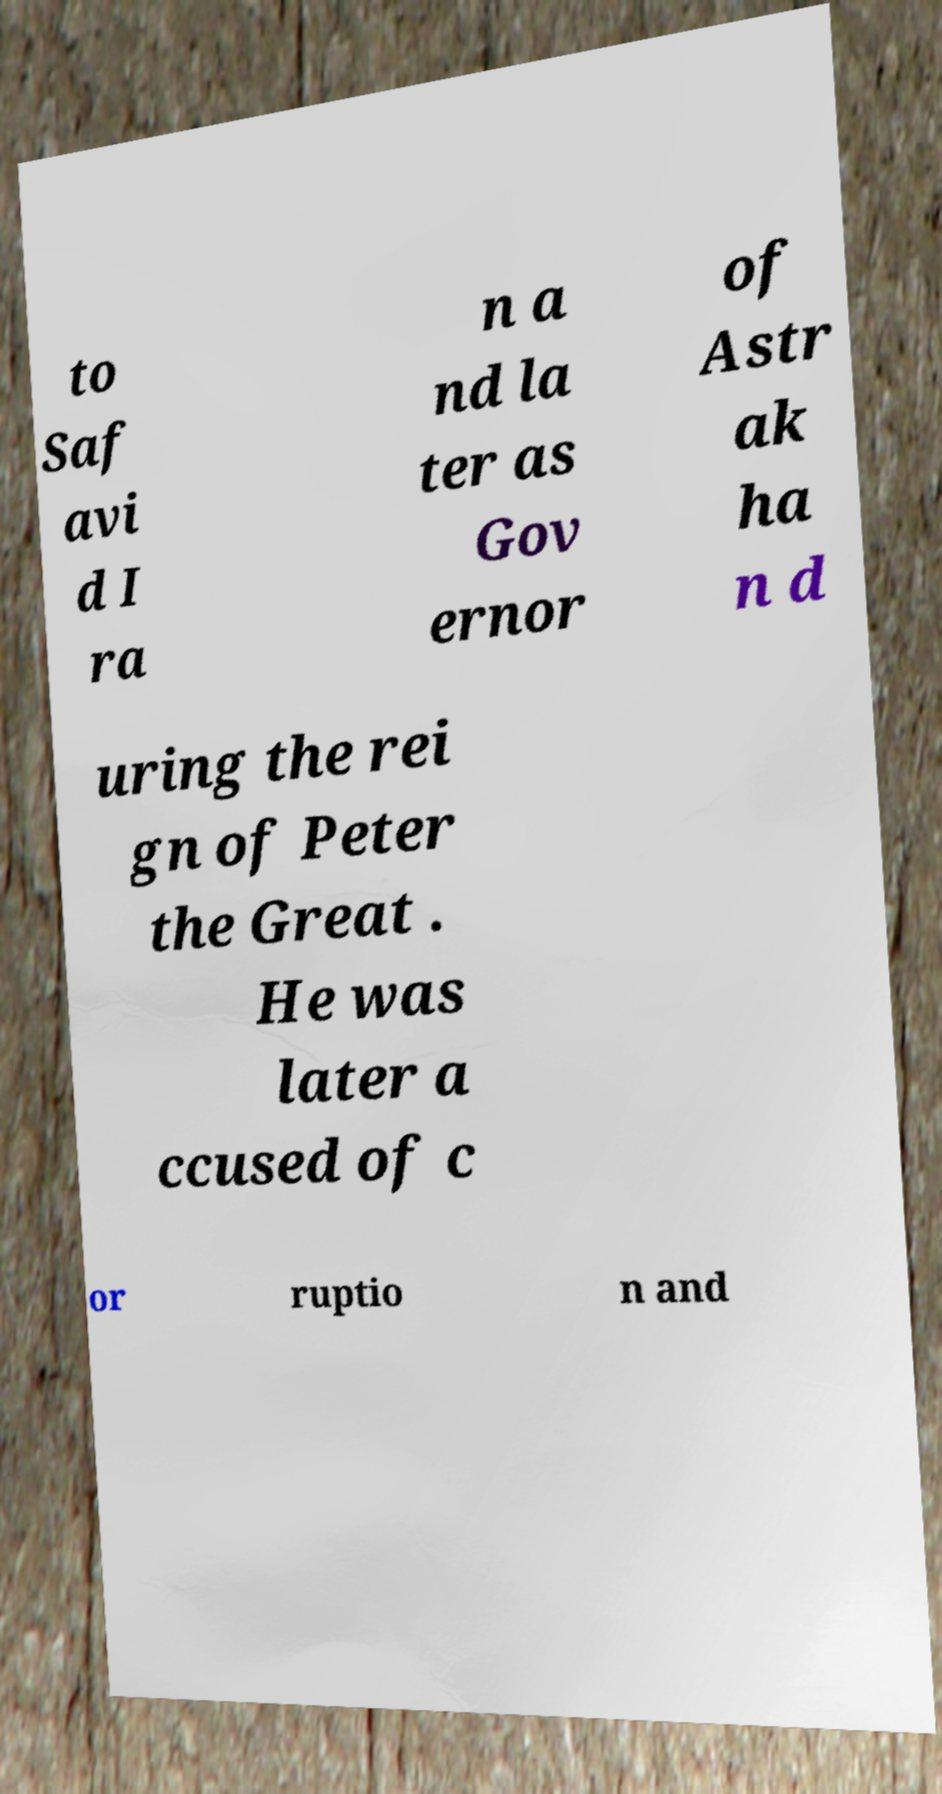There's text embedded in this image that I need extracted. Can you transcribe it verbatim? to Saf avi d I ra n a nd la ter as Gov ernor of Astr ak ha n d uring the rei gn of Peter the Great . He was later a ccused of c or ruptio n and 